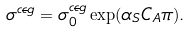<formula> <loc_0><loc_0><loc_500><loc_500>\sigma ^ { c \overline { c } g } = \sigma _ { 0 } ^ { c \overline { c } g } \exp ( \alpha _ { S } C _ { A } \pi ) .</formula> 